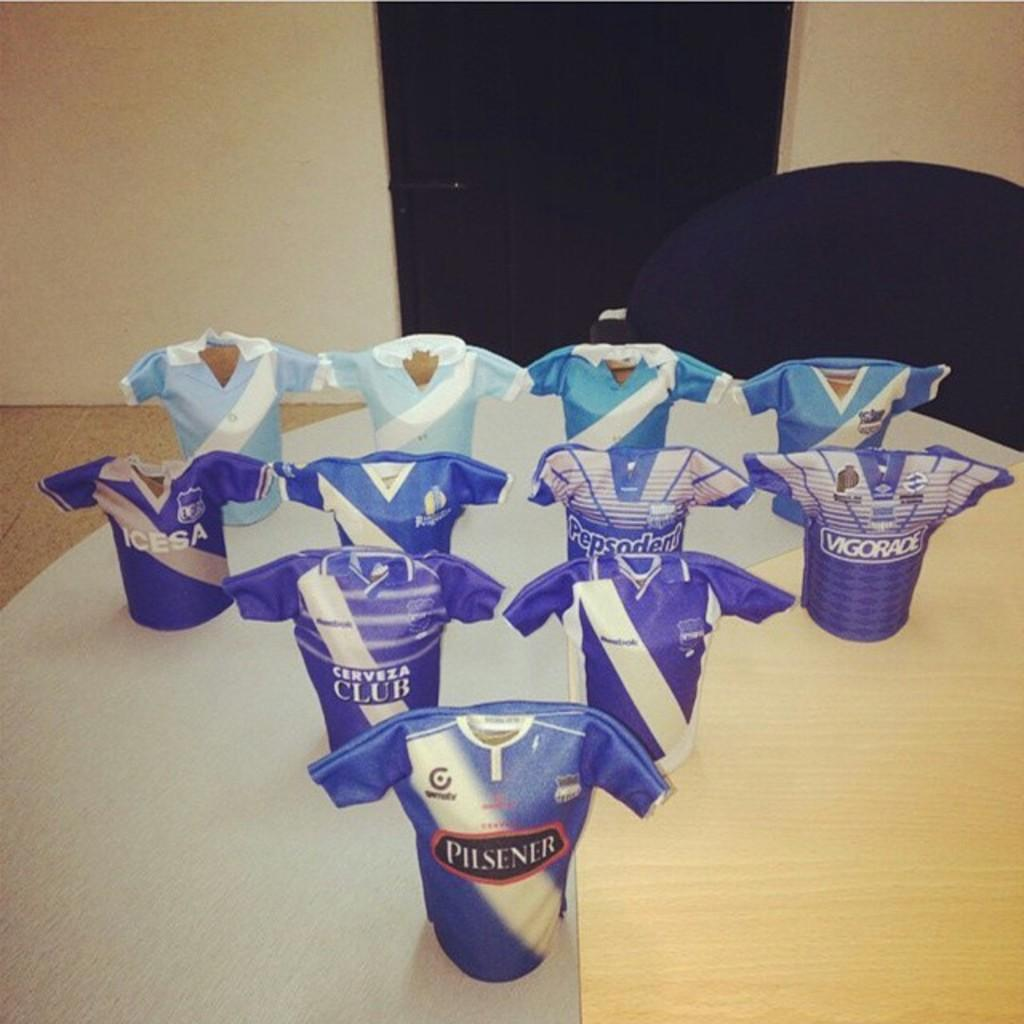<image>
Present a compact description of the photo's key features. A blue shirt with pilsner on the font is in front of other blue shirts. 